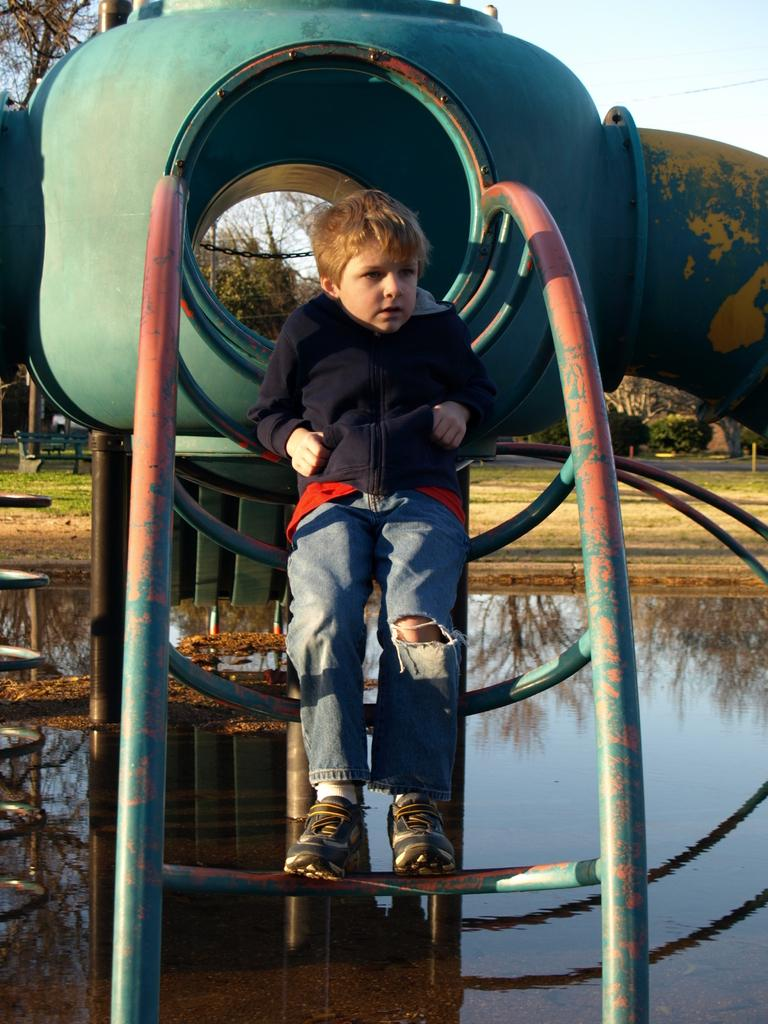Who is in the image? There is a boy in the image. What is the boy doing in the image? The boy is on a metal ladder. What can be seen in the background of the image? There are trees in the background of the image. What is the condition of the sky in the image? The sky is blue and cloudy. What type of support is the boy using to play the guitar in the image? There is no guitar present in the image, so there is no support being used for playing a guitar. 